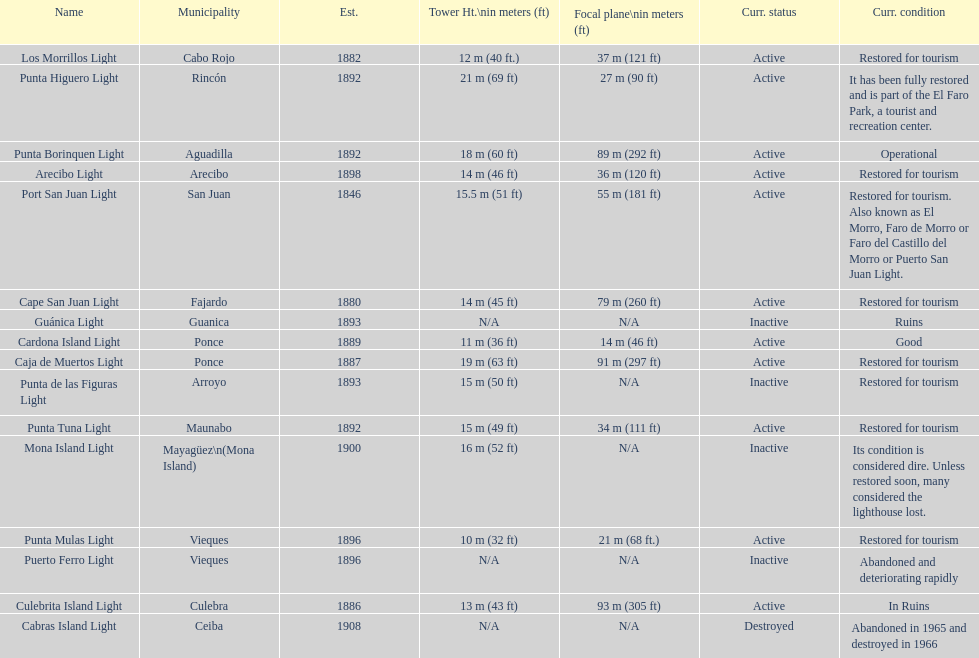The difference in years from 1882 to 1889 7. 